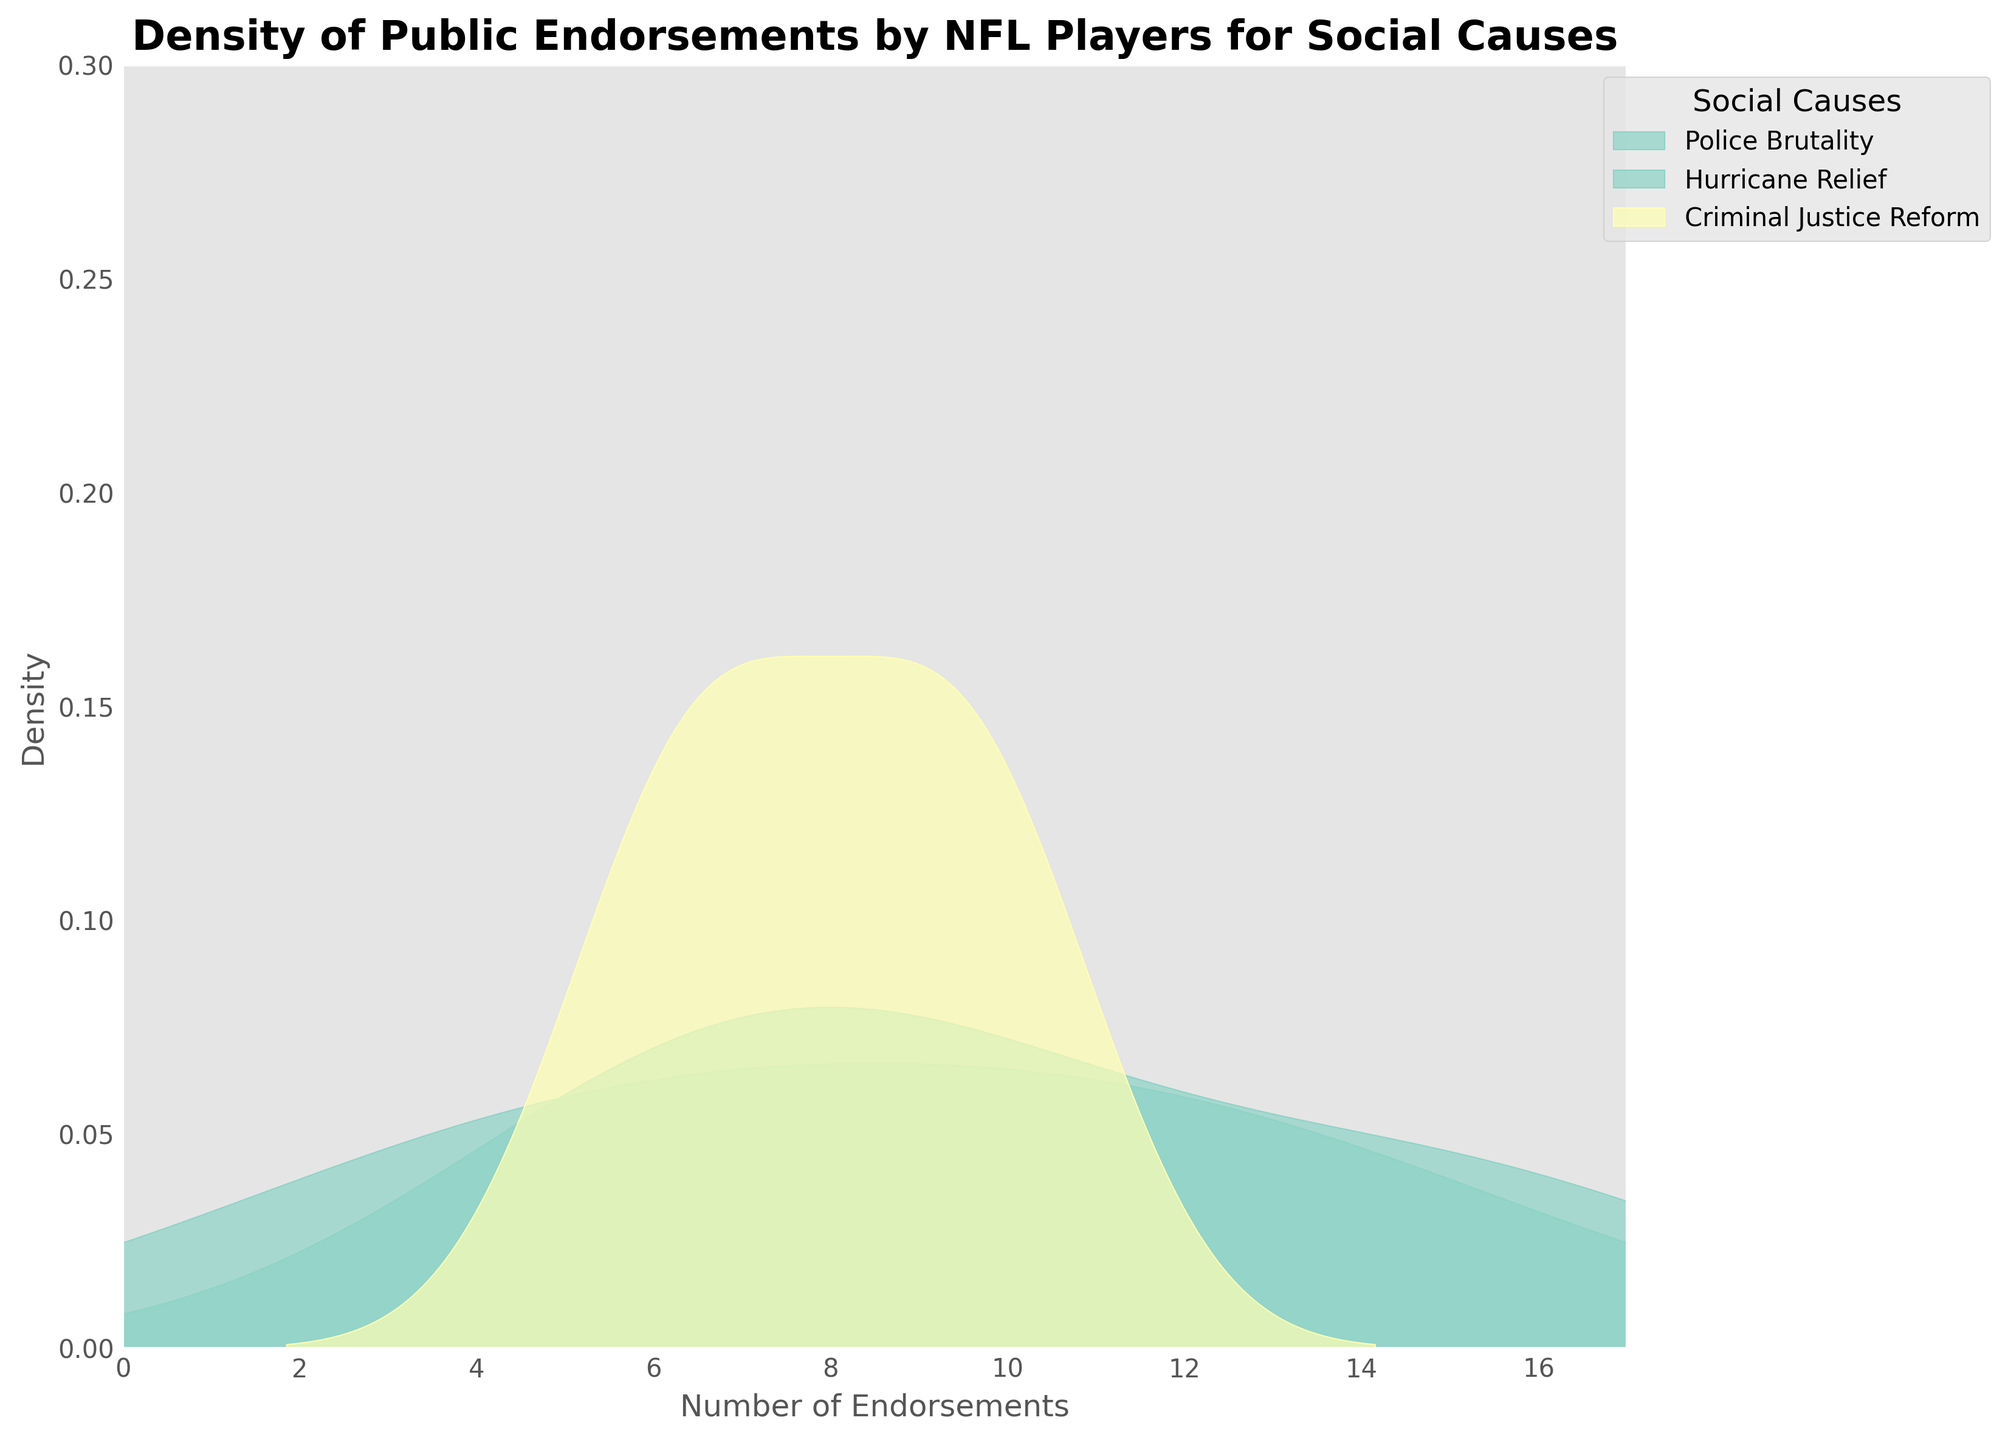What's the title of the figure? The title is usually displayed at the top of the figure in bold font. It summarizes what the figure is about.
Answer: Density of Public Endorsements by NFL Players for Social Causes What is the x-axis labeled as? The x-axis label is positioned horizontally below the x-axis and indicates what the x-axis represents.
Answer: Number of Endorsements Which cause shows the highest density peak? The highest density peak represents the maximum density value for one of the causes on the figure. Identifying this requires checking the peaks of all density plots.
Answer: Police Brutality How many social causes are being represented in the plot? The plot legend lists all the unique social causes present in the data. Counting these labels will give the answer.
Answer: 12 Which cause(s) have a density peak at around 7 endorsements? By observing the density curves, identify which ones peak at or around the 7 endorsement mark.
Answer: Military Support, Mental Health What are the limits of the x-axis? The x-axis limits are the minimum and maximum values set for the x-axis. These can usually be found at the very start and end of the x-axis line.
Answer: 0 to 17 Which causes are represented by the most distinct density curves (without overlap)? Identifying distinct curves involves looking for those with minimal or no overlap with other curves.
Answer: Police Brutality, Hurricane Relief Which cause shows the broadest range of endorsements? The broadest range of endorsements will show a spread-out density plot over a larger range on the x-axis.
Answer: Education Initiatives For Police Brutality and Hurricane Relief, which one has a higher density at 10 endorsements? Comparing the density values directly at the 10 endorsements point for both these causes will give the answer.
Answer: Police Brutality Which cause has the narrowest density curve? The narrowest density curve indicates the least variability, showing as a tight peak on the plot.
Answer: Voter Registration 